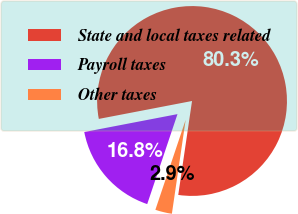Convert chart. <chart><loc_0><loc_0><loc_500><loc_500><pie_chart><fcel>State and local taxes related<fcel>Payroll taxes<fcel>Other taxes<nl><fcel>80.34%<fcel>16.81%<fcel>2.85%<nl></chart> 